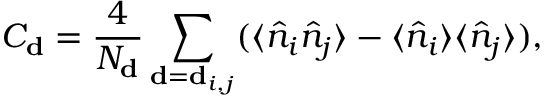Convert formula to latex. <formula><loc_0><loc_0><loc_500><loc_500>C _ { d } = \frac { 4 } { N _ { d } } \sum _ { d = d _ { i , j } } ( \langle \hat { n } _ { i } \hat { n } _ { j } \rangle - \langle \hat { n } _ { i } \rangle \langle \hat { n } _ { j } \rangle ) ,</formula> 